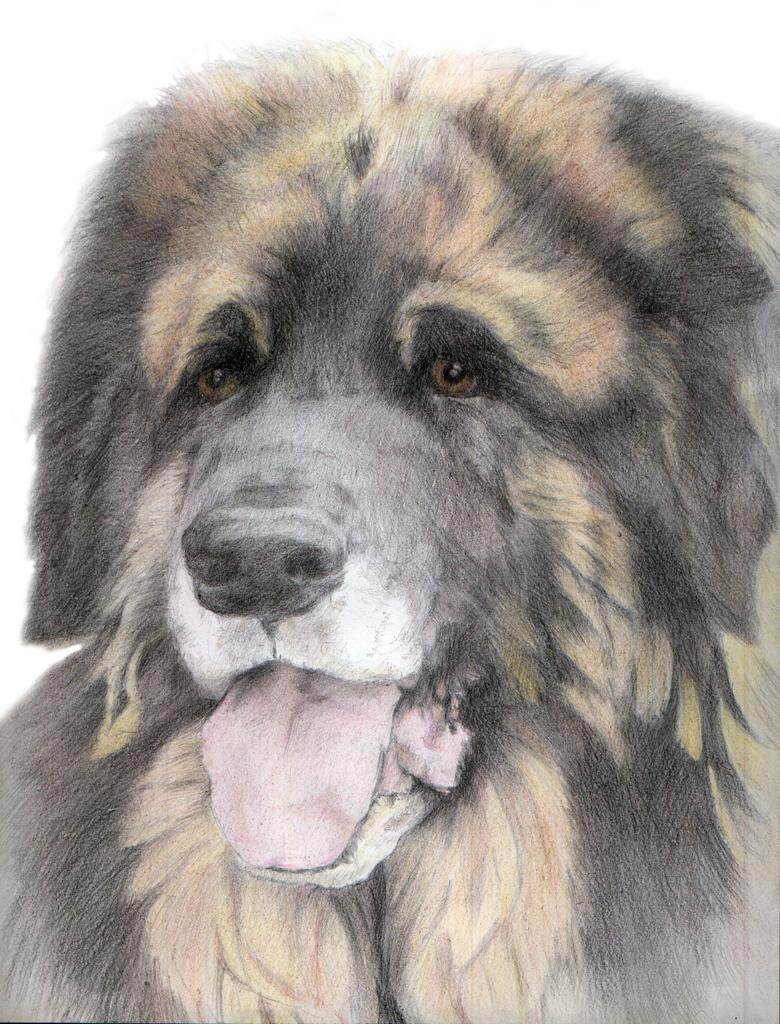Please provide a concise description of this image. In the center of the image a dog is present. 